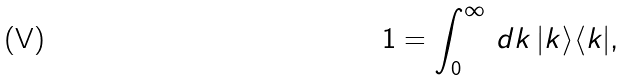Convert formula to latex. <formula><loc_0><loc_0><loc_500><loc_500>1 = \int _ { 0 } ^ { \infty } \, d k \, | k \rangle \langle k | ,</formula> 